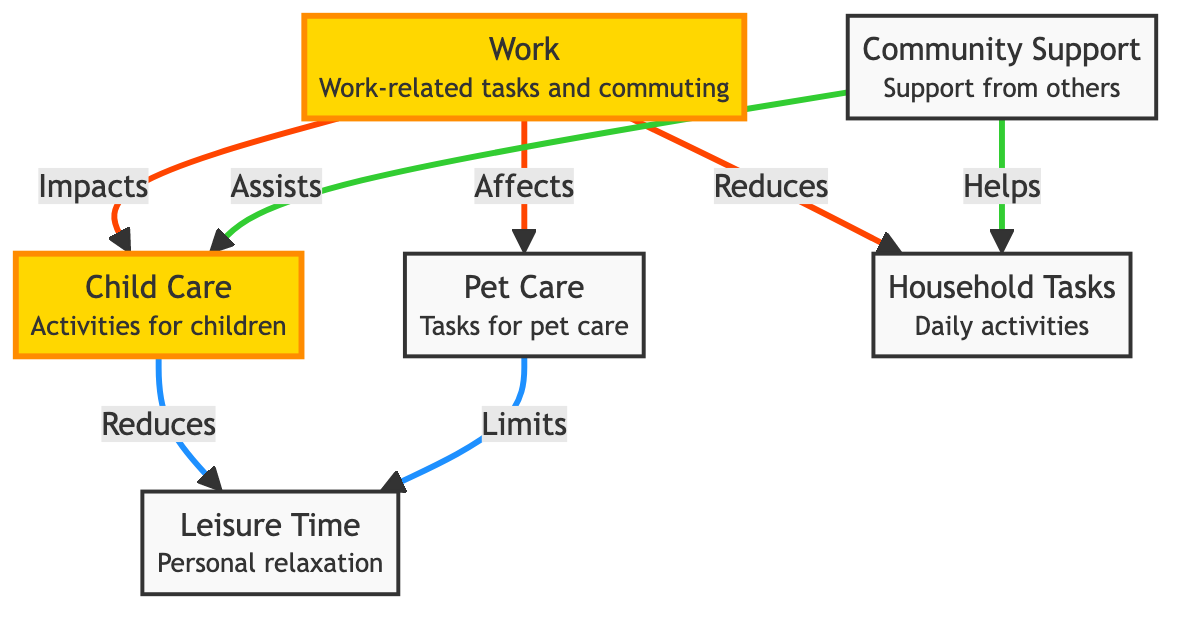What's the total number of nodes in the diagram? The diagram contains six nodes: Work, Child Care, Pet Care, Household Tasks, Leisure Time, and Community Support.
Answer: 6 What does Work impact in the diagram? According to the arrows in the diagram, Work impacts Child Care, affects Pet Care, and reduces Household Tasks.
Answer: Child Care, Pet Care, Household Tasks How does Child Care affect Leisure Time? The diagram shows a directional arrow from Child Care to Leisure Time labeled "Reduces", indicating that Child Care decreases the amount of Leisure Time.
Answer: Reduces Which node is assisted by Community Support? The arrows indicate that Community Support assists Child Care and helps with Household Tasks. Therefore, both nodes are supported by Community Support.
Answer: Child Care, Household Tasks What is the relationship between Pet Care and Leisure Time? The diagram has an arrow from Pet Care to Leisure Time labeled "Limits", which shows that Pet Care has a limiting effect on Leisure Time.
Answer: Limits Identify the connection type between Work and Child Care. The diagram shows an arrow from Work to Child Care labeled "Impacts", suggesting a direct influence or effect between Work and Child Care.
Answer: Impacts What effects does Community Support have on tasks in the diagram? Community Support connects to two nodes: it assists Child Care and helps with Household Tasks, indicating its supportive role related to these areas.
Answer: Assists, Helps Why does Work reduce Household Tasks based on the diagram? The diagram indicates a relationship where Work reduces Household Tasks, suggesting that as work responsibilities increase, less time is available for household chores.
Answer: Reduces What kind of relationship exists between Leisure Time and Child Care? The diagram shows that Child Care reduces Leisure Time, indicating a negative relationship where increased child care activities result in decreased leisure time for the parent.
Answer: Reduces 